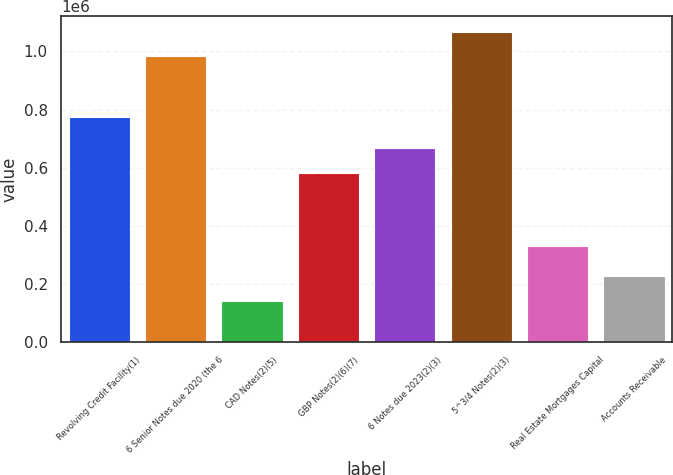Convert chart. <chart><loc_0><loc_0><loc_500><loc_500><bar_chart><fcel>Revolving Credit Facility(1)<fcel>6 Senior Notes due 2020 (the 6<fcel>CAD Notes(2)(5)<fcel>GBP Notes(2)(6)(7)<fcel>6 Notes due 2023(2)(3)<fcel>5^3/4 Notes(2)(3)<fcel>Real Estate Mortgages Capital<fcel>Accounts Receivable<nl><fcel>775028<fcel>983876<fcel>142266<fcel>583383<fcel>667966<fcel>1.06846e+06<fcel>332489<fcel>226849<nl></chart> 